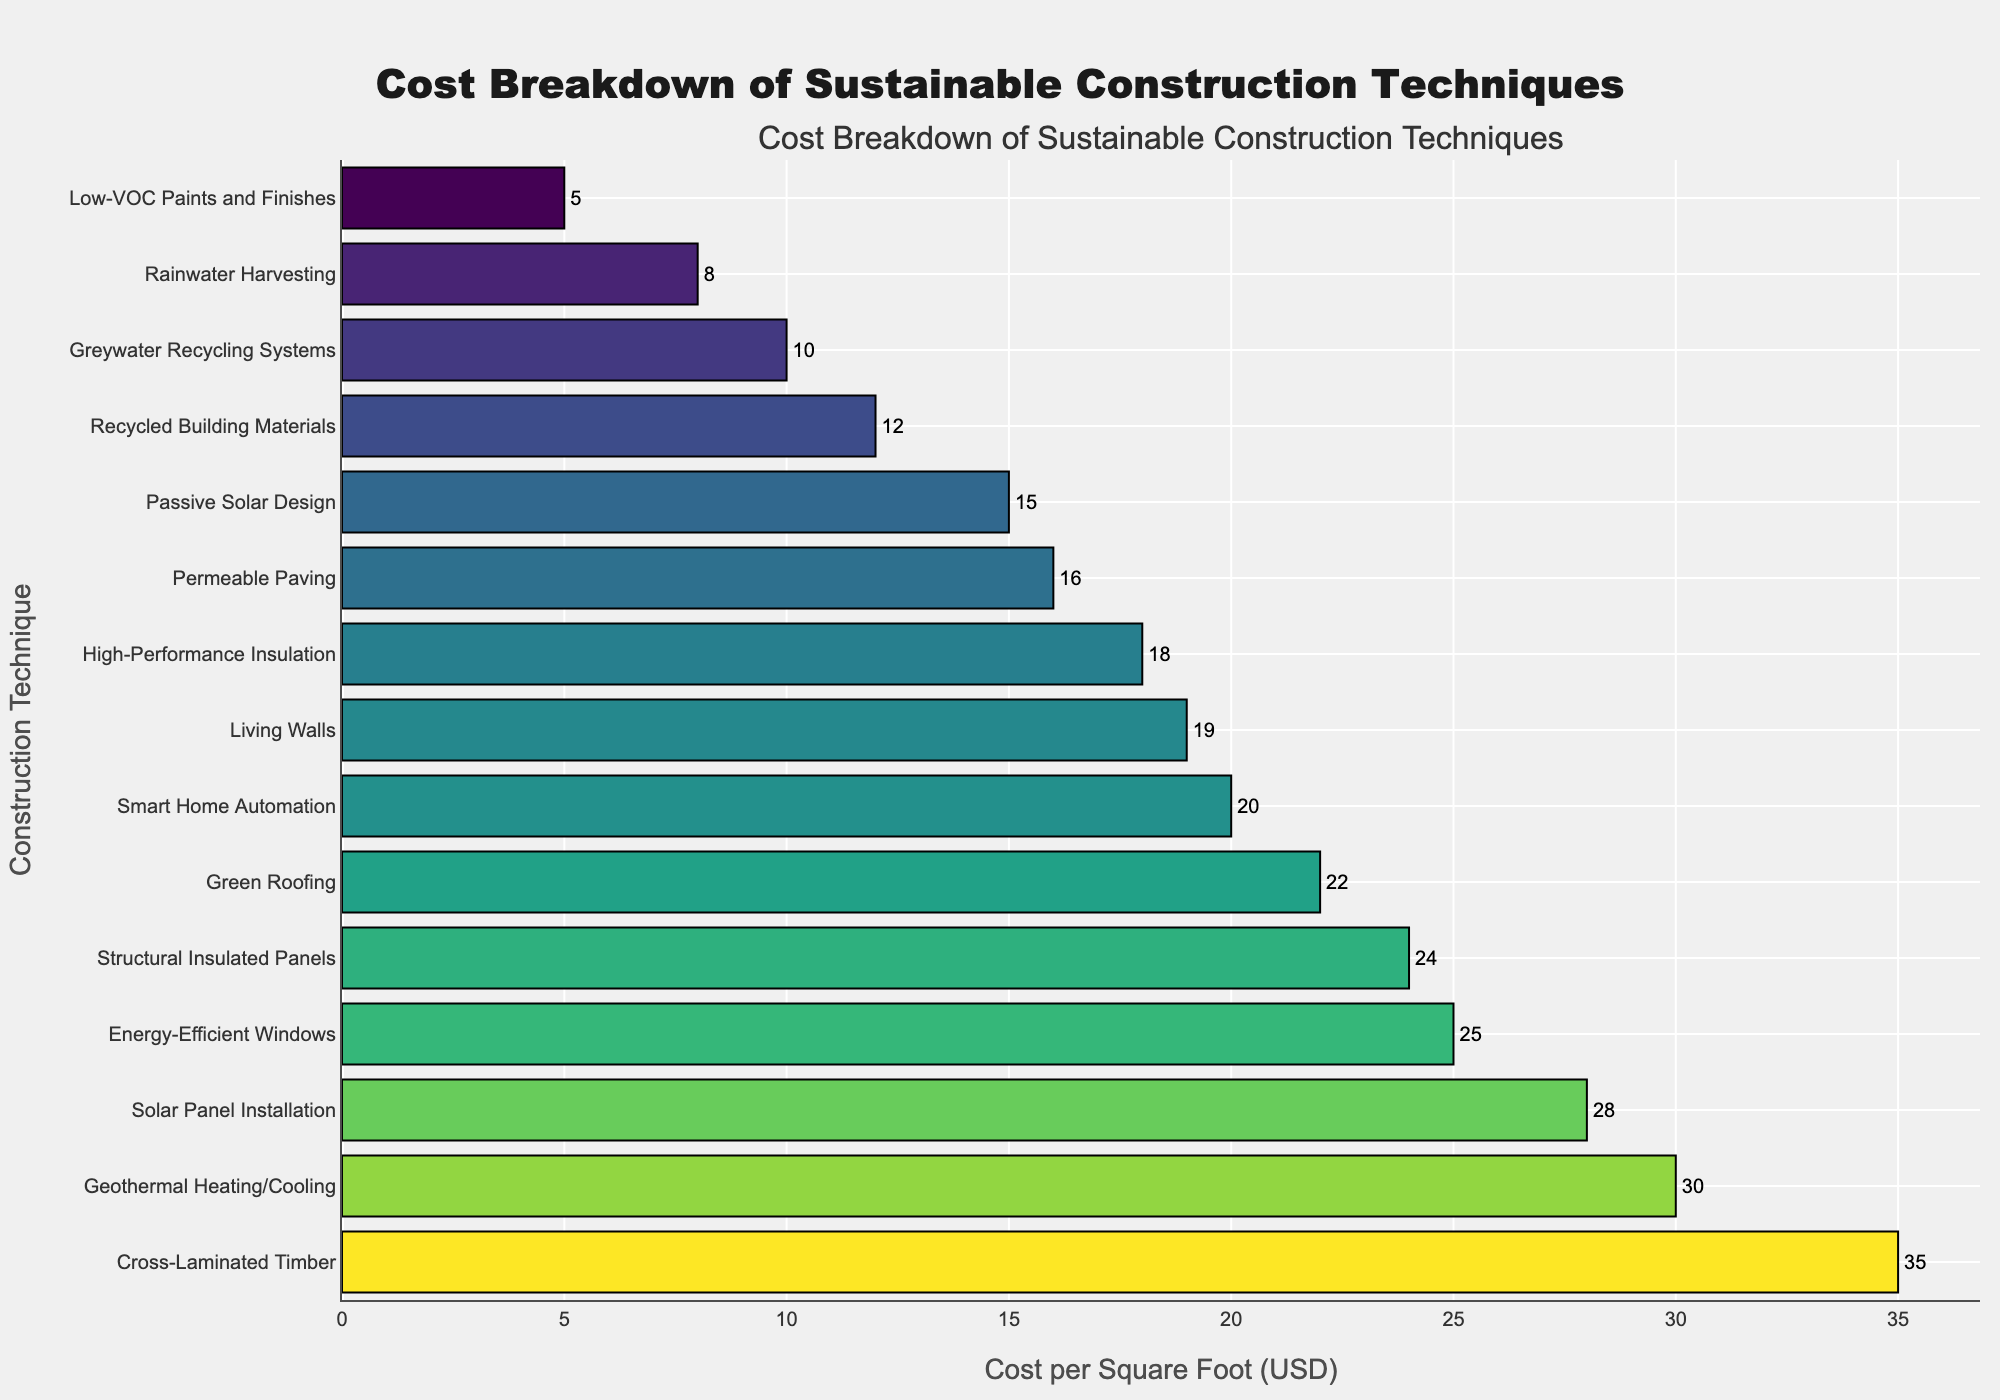Which construction technique is the most expensive? The bar chart shows all the construction techniques in descending order of cost. The first one is the most expensive.
Answer: Cross-Laminated Timber Which construction technique is the least expensive? The bar chart shows all the construction techniques in descending order of cost. The last one is the least expensive.
Answer: Low-VOC Paints and Finishes What is the cost difference between the most expensive and least expensive construction techniques? The cost per square foot of the most expensive technique (Cross-Laminated Timber) is $35. The cost per square foot of the least expensive technique (Low-VOC Paints and Finishes) is $5. The difference is $35 - $5 = $30.
Answer: $30 Which construction techniques have a cost per square foot greater than $25? By examining the bar lengths and the text labels in the chart, the techniques with a cost per square foot greater than $25 include Energy-Efficient Windows ($25), Geothermal Heating/Cooling ($30), Solar Panel Installation ($28), and Cross-Laminated Timber ($35).
Answer: Energy-Efficient Windows, Geothermal Heating/Cooling, Solar Panel Installation, Cross-Laminated Timber What is the combined cost per square foot of Green Roofing and Smart Home Automation? Green Roofing costs $22 per square foot and Smart Home Automation costs $20 per square foot. Their combined cost is $22 + $20 = $42.
Answer: $42 Which construction technique has a similar cost to High-Performance Insulation? By visually inspecting the lengths of the bars and the cost values, Living Walls, which costs $19 per square foot, is the closest to High-Performance Insulation, which costs $18 per square foot.
Answer: Living Walls What is the average cost per square foot for the techniques: Rainwater Harvesting, High-Performance Insulation, and Greywater Recycling Systems? The costs per square foot for these techniques are $8 (Rainwater Harvesting), $18 (High-Performance Insulation), and $10 (Greywater Recycling Systems). Their average cost is calculated as (8 + 18 + 10) / 3 = 36 / 3 = 12.
Answer: $12 How does the cost of Recycled Building Materials compare to that of Passive Solar Design? According to the bar chart, Recycled Building Materials costs $12 per square foot and Passive Solar Design costs $15 per square foot. Therefore, Recycled Building Materials is less expensive.
Answer: Less expensive Identify the construction techniques that fall within the $20 to $25 per square foot range. By examining the bar lengths and text labels, techniques in this range include Smart Home Automation ($20), Structural Insulated Panels ($24), and Energy-Efficient Windows ($25).
Answer: Smart Home Automation, Structural Insulated Panels, Energy-Efficient Windows 